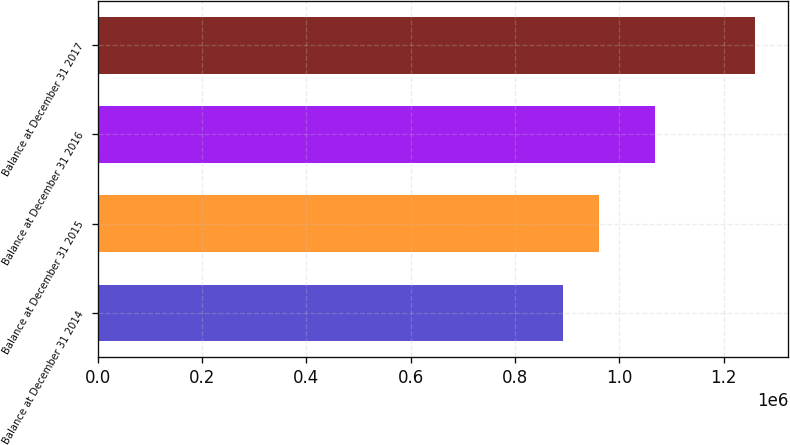<chart> <loc_0><loc_0><loc_500><loc_500><bar_chart><fcel>Balance at December 31 2014<fcel>Balance at December 31 2015<fcel>Balance at December 31 2016<fcel>Balance at December 31 2017<nl><fcel>891831<fcel>961456<fcel>1.06899e+06<fcel>1.26017e+06<nl></chart> 